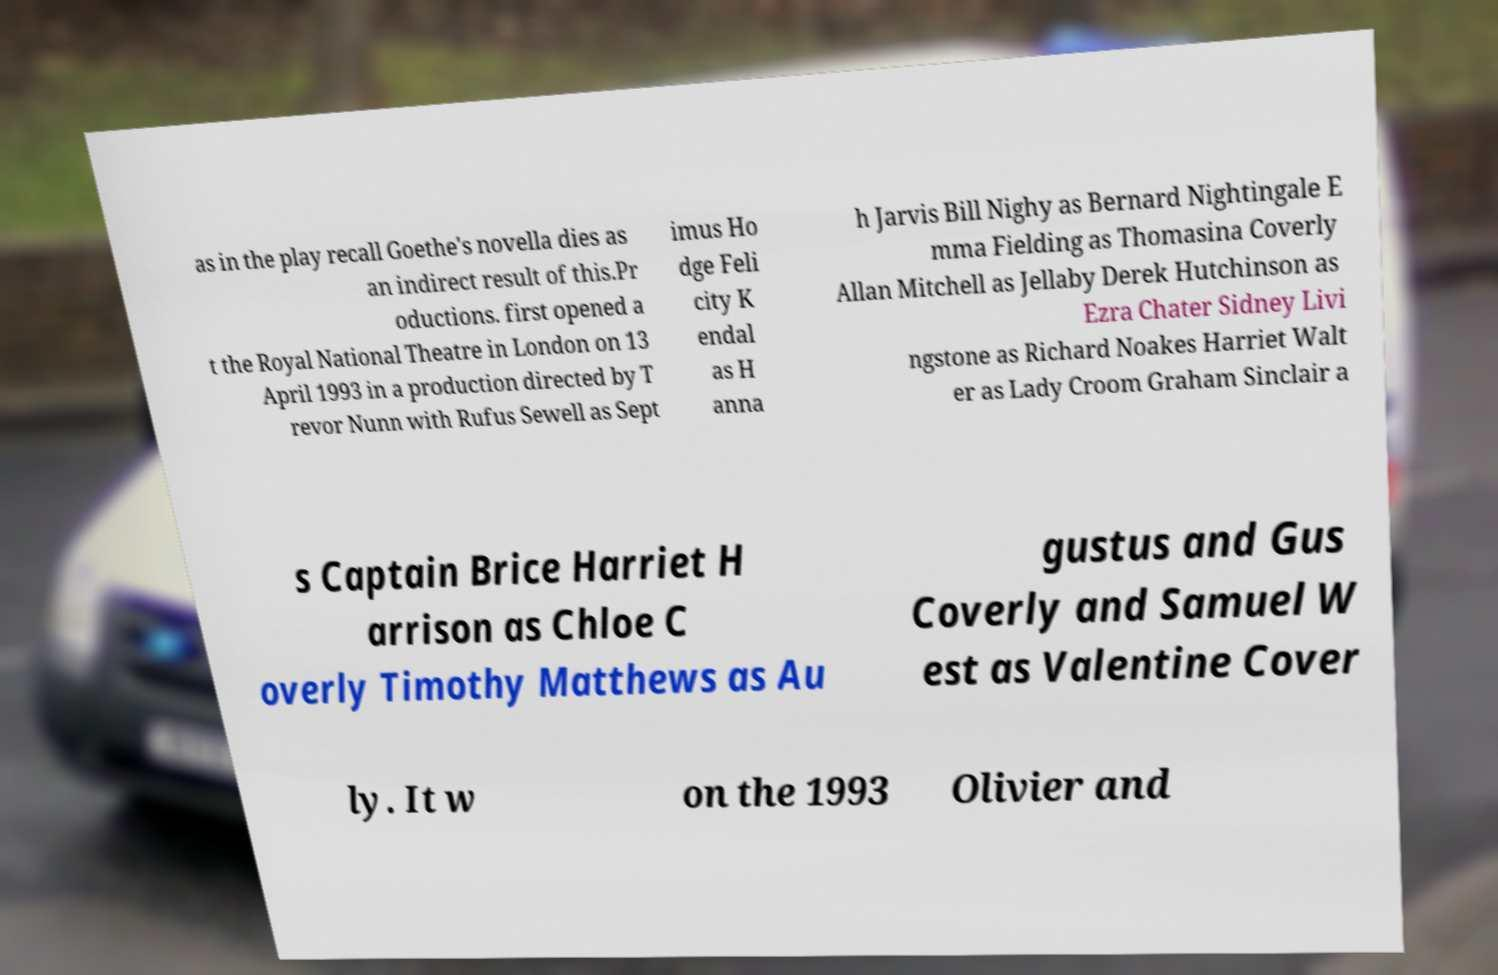Can you accurately transcribe the text from the provided image for me? as in the play recall Goethe's novella dies as an indirect result of this.Pr oductions. first opened a t the Royal National Theatre in London on 13 April 1993 in a production directed by T revor Nunn with Rufus Sewell as Sept imus Ho dge Feli city K endal as H anna h Jarvis Bill Nighy as Bernard Nightingale E mma Fielding as Thomasina Coverly Allan Mitchell as Jellaby Derek Hutchinson as Ezra Chater Sidney Livi ngstone as Richard Noakes Harriet Walt er as Lady Croom Graham Sinclair a s Captain Brice Harriet H arrison as Chloe C overly Timothy Matthews as Au gustus and Gus Coverly and Samuel W est as Valentine Cover ly. It w on the 1993 Olivier and 